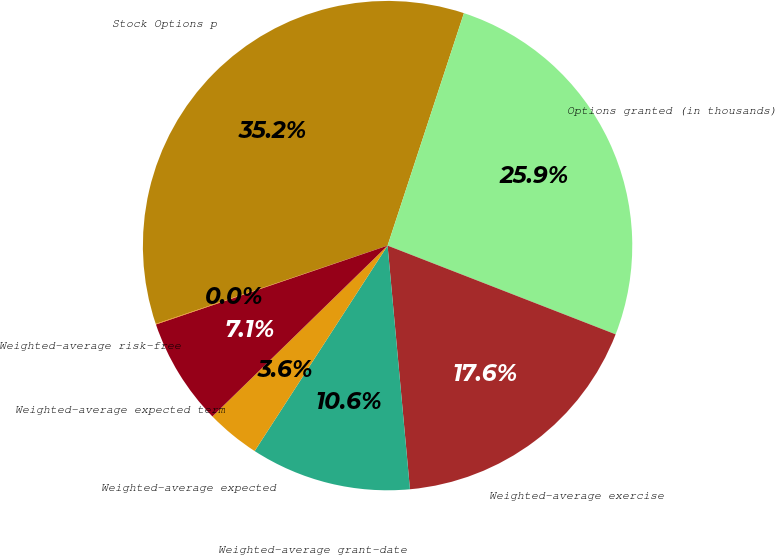Convert chart. <chart><loc_0><loc_0><loc_500><loc_500><pie_chart><fcel>Stock Options p<fcel>Options granted (in thousands)<fcel>Weighted-average exercise<fcel>Weighted-average grant-date<fcel>Weighted-average expected<fcel>Weighted-average expected term<fcel>Weighted-average risk-free<nl><fcel>35.24%<fcel>25.86%<fcel>17.64%<fcel>10.6%<fcel>3.56%<fcel>7.08%<fcel>0.04%<nl></chart> 